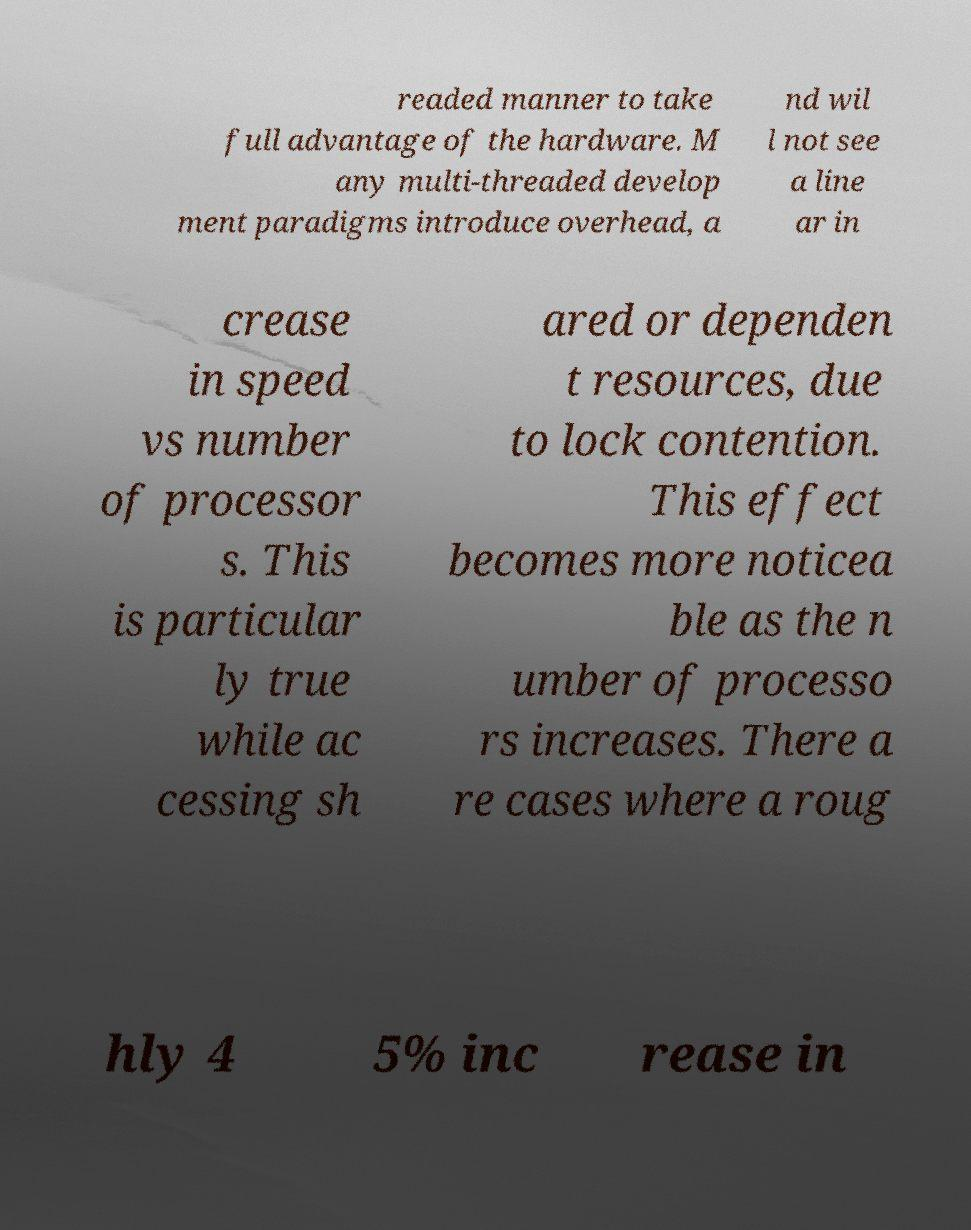Can you accurately transcribe the text from the provided image for me? readed manner to take full advantage of the hardware. M any multi-threaded develop ment paradigms introduce overhead, a nd wil l not see a line ar in crease in speed vs number of processor s. This is particular ly true while ac cessing sh ared or dependen t resources, due to lock contention. This effect becomes more noticea ble as the n umber of processo rs increases. There a re cases where a roug hly 4 5% inc rease in 